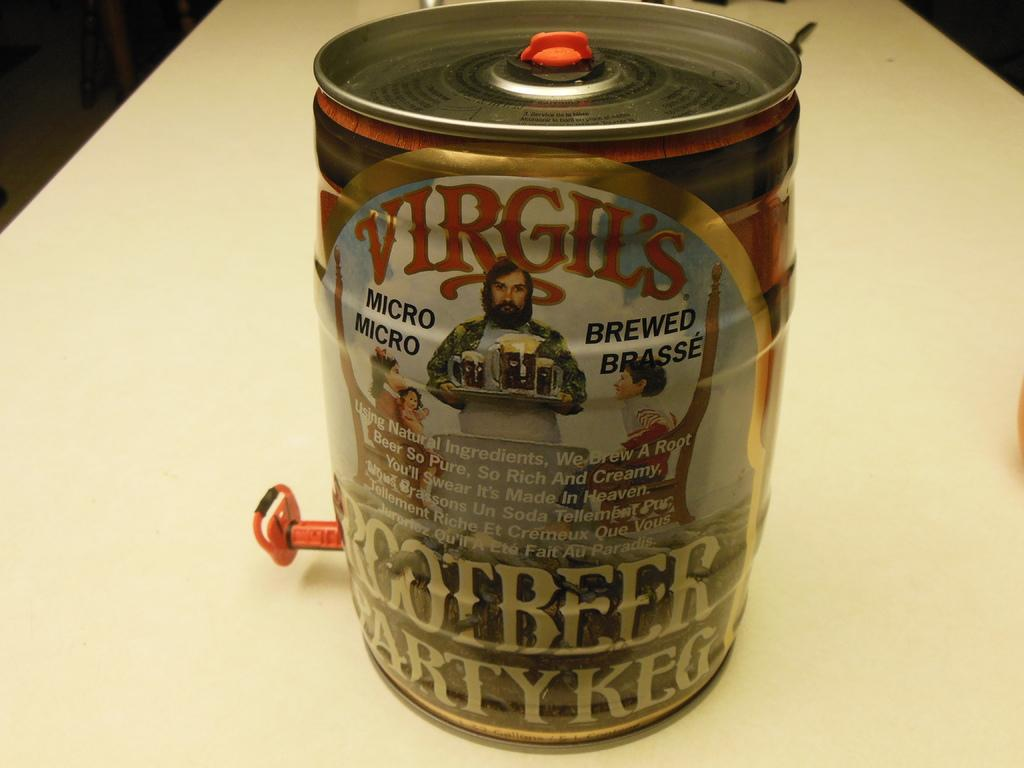<image>
Create a compact narrative representing the image presented. A virgil's rootbeer party keg is sitting on the floor. 